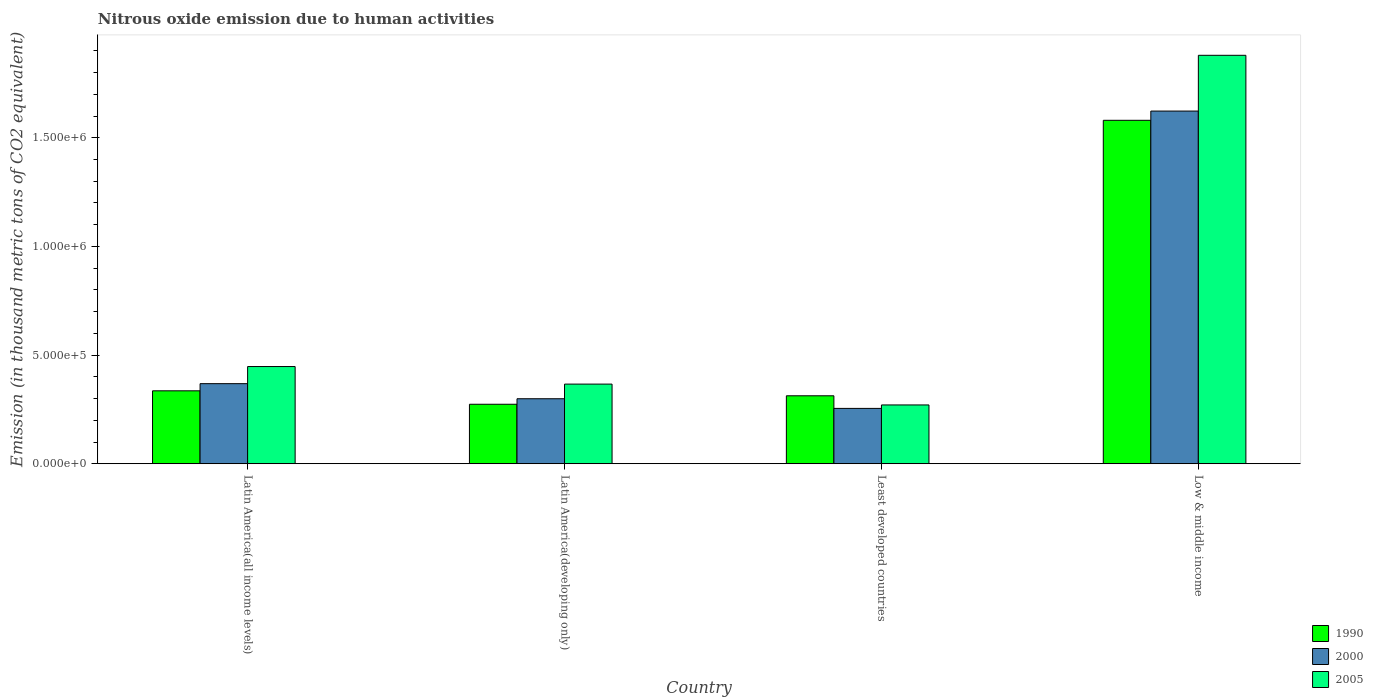How many different coloured bars are there?
Make the answer very short. 3. How many groups of bars are there?
Make the answer very short. 4. Are the number of bars per tick equal to the number of legend labels?
Make the answer very short. Yes. Are the number of bars on each tick of the X-axis equal?
Make the answer very short. Yes. What is the label of the 4th group of bars from the left?
Ensure brevity in your answer.  Low & middle income. In how many cases, is the number of bars for a given country not equal to the number of legend labels?
Give a very brief answer. 0. What is the amount of nitrous oxide emitted in 1990 in Latin America(developing only)?
Give a very brief answer. 2.74e+05. Across all countries, what is the maximum amount of nitrous oxide emitted in 2000?
Offer a very short reply. 1.62e+06. Across all countries, what is the minimum amount of nitrous oxide emitted in 2000?
Provide a succinct answer. 2.55e+05. In which country was the amount of nitrous oxide emitted in 2000 maximum?
Offer a very short reply. Low & middle income. In which country was the amount of nitrous oxide emitted in 1990 minimum?
Offer a terse response. Latin America(developing only). What is the total amount of nitrous oxide emitted in 2000 in the graph?
Offer a very short reply. 2.55e+06. What is the difference between the amount of nitrous oxide emitted in 2000 in Latin America(developing only) and that in Least developed countries?
Offer a terse response. 4.44e+04. What is the difference between the amount of nitrous oxide emitted in 2000 in Low & middle income and the amount of nitrous oxide emitted in 1990 in Least developed countries?
Make the answer very short. 1.31e+06. What is the average amount of nitrous oxide emitted in 2005 per country?
Make the answer very short. 7.41e+05. What is the difference between the amount of nitrous oxide emitted of/in 2000 and amount of nitrous oxide emitted of/in 1990 in Least developed countries?
Offer a terse response. -5.80e+04. What is the ratio of the amount of nitrous oxide emitted in 1990 in Latin America(all income levels) to that in Latin America(developing only)?
Ensure brevity in your answer.  1.23. Is the difference between the amount of nitrous oxide emitted in 2000 in Latin America(all income levels) and Latin America(developing only) greater than the difference between the amount of nitrous oxide emitted in 1990 in Latin America(all income levels) and Latin America(developing only)?
Make the answer very short. Yes. What is the difference between the highest and the second highest amount of nitrous oxide emitted in 2005?
Provide a succinct answer. -8.08e+04. What is the difference between the highest and the lowest amount of nitrous oxide emitted in 1990?
Your answer should be very brief. 1.31e+06. In how many countries, is the amount of nitrous oxide emitted in 2000 greater than the average amount of nitrous oxide emitted in 2000 taken over all countries?
Give a very brief answer. 1. Is the sum of the amount of nitrous oxide emitted in 2005 in Latin America(all income levels) and Low & middle income greater than the maximum amount of nitrous oxide emitted in 1990 across all countries?
Ensure brevity in your answer.  Yes. Is it the case that in every country, the sum of the amount of nitrous oxide emitted in 1990 and amount of nitrous oxide emitted in 2005 is greater than the amount of nitrous oxide emitted in 2000?
Your response must be concise. Yes. How many bars are there?
Offer a very short reply. 12. Does the graph contain grids?
Give a very brief answer. No. Where does the legend appear in the graph?
Provide a short and direct response. Bottom right. What is the title of the graph?
Keep it short and to the point. Nitrous oxide emission due to human activities. What is the label or title of the Y-axis?
Make the answer very short. Emission (in thousand metric tons of CO2 equivalent). What is the Emission (in thousand metric tons of CO2 equivalent) of 1990 in Latin America(all income levels)?
Ensure brevity in your answer.  3.36e+05. What is the Emission (in thousand metric tons of CO2 equivalent) in 2000 in Latin America(all income levels)?
Your response must be concise. 3.68e+05. What is the Emission (in thousand metric tons of CO2 equivalent) in 2005 in Latin America(all income levels)?
Keep it short and to the point. 4.47e+05. What is the Emission (in thousand metric tons of CO2 equivalent) in 1990 in Latin America(developing only)?
Provide a short and direct response. 2.74e+05. What is the Emission (in thousand metric tons of CO2 equivalent) of 2000 in Latin America(developing only)?
Offer a very short reply. 2.99e+05. What is the Emission (in thousand metric tons of CO2 equivalent) in 2005 in Latin America(developing only)?
Your answer should be compact. 3.66e+05. What is the Emission (in thousand metric tons of CO2 equivalent) of 1990 in Least developed countries?
Offer a terse response. 3.13e+05. What is the Emission (in thousand metric tons of CO2 equivalent) of 2000 in Least developed countries?
Your answer should be very brief. 2.55e+05. What is the Emission (in thousand metric tons of CO2 equivalent) of 2005 in Least developed countries?
Provide a short and direct response. 2.71e+05. What is the Emission (in thousand metric tons of CO2 equivalent) in 1990 in Low & middle income?
Keep it short and to the point. 1.58e+06. What is the Emission (in thousand metric tons of CO2 equivalent) of 2000 in Low & middle income?
Make the answer very short. 1.62e+06. What is the Emission (in thousand metric tons of CO2 equivalent) in 2005 in Low & middle income?
Keep it short and to the point. 1.88e+06. Across all countries, what is the maximum Emission (in thousand metric tons of CO2 equivalent) in 1990?
Make the answer very short. 1.58e+06. Across all countries, what is the maximum Emission (in thousand metric tons of CO2 equivalent) of 2000?
Offer a very short reply. 1.62e+06. Across all countries, what is the maximum Emission (in thousand metric tons of CO2 equivalent) in 2005?
Your response must be concise. 1.88e+06. Across all countries, what is the minimum Emission (in thousand metric tons of CO2 equivalent) in 1990?
Keep it short and to the point. 2.74e+05. Across all countries, what is the minimum Emission (in thousand metric tons of CO2 equivalent) of 2000?
Your response must be concise. 2.55e+05. Across all countries, what is the minimum Emission (in thousand metric tons of CO2 equivalent) in 2005?
Keep it short and to the point. 2.71e+05. What is the total Emission (in thousand metric tons of CO2 equivalent) of 1990 in the graph?
Make the answer very short. 2.50e+06. What is the total Emission (in thousand metric tons of CO2 equivalent) in 2000 in the graph?
Provide a succinct answer. 2.55e+06. What is the total Emission (in thousand metric tons of CO2 equivalent) of 2005 in the graph?
Offer a very short reply. 2.96e+06. What is the difference between the Emission (in thousand metric tons of CO2 equivalent) of 1990 in Latin America(all income levels) and that in Latin America(developing only)?
Your response must be concise. 6.18e+04. What is the difference between the Emission (in thousand metric tons of CO2 equivalent) of 2000 in Latin America(all income levels) and that in Latin America(developing only)?
Give a very brief answer. 6.94e+04. What is the difference between the Emission (in thousand metric tons of CO2 equivalent) of 2005 in Latin America(all income levels) and that in Latin America(developing only)?
Your answer should be compact. 8.08e+04. What is the difference between the Emission (in thousand metric tons of CO2 equivalent) of 1990 in Latin America(all income levels) and that in Least developed countries?
Provide a short and direct response. 2.29e+04. What is the difference between the Emission (in thousand metric tons of CO2 equivalent) in 2000 in Latin America(all income levels) and that in Least developed countries?
Your answer should be compact. 1.14e+05. What is the difference between the Emission (in thousand metric tons of CO2 equivalent) in 2005 in Latin America(all income levels) and that in Least developed countries?
Your response must be concise. 1.77e+05. What is the difference between the Emission (in thousand metric tons of CO2 equivalent) of 1990 in Latin America(all income levels) and that in Low & middle income?
Give a very brief answer. -1.24e+06. What is the difference between the Emission (in thousand metric tons of CO2 equivalent) in 2000 in Latin America(all income levels) and that in Low & middle income?
Provide a succinct answer. -1.25e+06. What is the difference between the Emission (in thousand metric tons of CO2 equivalent) in 2005 in Latin America(all income levels) and that in Low & middle income?
Provide a short and direct response. -1.43e+06. What is the difference between the Emission (in thousand metric tons of CO2 equivalent) of 1990 in Latin America(developing only) and that in Least developed countries?
Offer a very short reply. -3.90e+04. What is the difference between the Emission (in thousand metric tons of CO2 equivalent) of 2000 in Latin America(developing only) and that in Least developed countries?
Give a very brief answer. 4.44e+04. What is the difference between the Emission (in thousand metric tons of CO2 equivalent) of 2005 in Latin America(developing only) and that in Least developed countries?
Your answer should be very brief. 9.59e+04. What is the difference between the Emission (in thousand metric tons of CO2 equivalent) of 1990 in Latin America(developing only) and that in Low & middle income?
Your answer should be compact. -1.31e+06. What is the difference between the Emission (in thousand metric tons of CO2 equivalent) in 2000 in Latin America(developing only) and that in Low & middle income?
Offer a very short reply. -1.32e+06. What is the difference between the Emission (in thousand metric tons of CO2 equivalent) in 2005 in Latin America(developing only) and that in Low & middle income?
Ensure brevity in your answer.  -1.51e+06. What is the difference between the Emission (in thousand metric tons of CO2 equivalent) in 1990 in Least developed countries and that in Low & middle income?
Keep it short and to the point. -1.27e+06. What is the difference between the Emission (in thousand metric tons of CO2 equivalent) of 2000 in Least developed countries and that in Low & middle income?
Give a very brief answer. -1.37e+06. What is the difference between the Emission (in thousand metric tons of CO2 equivalent) in 2005 in Least developed countries and that in Low & middle income?
Keep it short and to the point. -1.61e+06. What is the difference between the Emission (in thousand metric tons of CO2 equivalent) in 1990 in Latin America(all income levels) and the Emission (in thousand metric tons of CO2 equivalent) in 2000 in Latin America(developing only)?
Keep it short and to the point. 3.65e+04. What is the difference between the Emission (in thousand metric tons of CO2 equivalent) in 1990 in Latin America(all income levels) and the Emission (in thousand metric tons of CO2 equivalent) in 2005 in Latin America(developing only)?
Keep it short and to the point. -3.09e+04. What is the difference between the Emission (in thousand metric tons of CO2 equivalent) of 2000 in Latin America(all income levels) and the Emission (in thousand metric tons of CO2 equivalent) of 2005 in Latin America(developing only)?
Ensure brevity in your answer.  2012. What is the difference between the Emission (in thousand metric tons of CO2 equivalent) of 1990 in Latin America(all income levels) and the Emission (in thousand metric tons of CO2 equivalent) of 2000 in Least developed countries?
Provide a short and direct response. 8.09e+04. What is the difference between the Emission (in thousand metric tons of CO2 equivalent) in 1990 in Latin America(all income levels) and the Emission (in thousand metric tons of CO2 equivalent) in 2005 in Least developed countries?
Make the answer very short. 6.50e+04. What is the difference between the Emission (in thousand metric tons of CO2 equivalent) in 2000 in Latin America(all income levels) and the Emission (in thousand metric tons of CO2 equivalent) in 2005 in Least developed countries?
Offer a very short reply. 9.79e+04. What is the difference between the Emission (in thousand metric tons of CO2 equivalent) in 1990 in Latin America(all income levels) and the Emission (in thousand metric tons of CO2 equivalent) in 2000 in Low & middle income?
Offer a very short reply. -1.29e+06. What is the difference between the Emission (in thousand metric tons of CO2 equivalent) in 1990 in Latin America(all income levels) and the Emission (in thousand metric tons of CO2 equivalent) in 2005 in Low & middle income?
Your answer should be compact. -1.54e+06. What is the difference between the Emission (in thousand metric tons of CO2 equivalent) of 2000 in Latin America(all income levels) and the Emission (in thousand metric tons of CO2 equivalent) of 2005 in Low & middle income?
Provide a short and direct response. -1.51e+06. What is the difference between the Emission (in thousand metric tons of CO2 equivalent) in 1990 in Latin America(developing only) and the Emission (in thousand metric tons of CO2 equivalent) in 2000 in Least developed countries?
Ensure brevity in your answer.  1.91e+04. What is the difference between the Emission (in thousand metric tons of CO2 equivalent) in 1990 in Latin America(developing only) and the Emission (in thousand metric tons of CO2 equivalent) in 2005 in Least developed countries?
Your response must be concise. 3144.7. What is the difference between the Emission (in thousand metric tons of CO2 equivalent) in 2000 in Latin America(developing only) and the Emission (in thousand metric tons of CO2 equivalent) in 2005 in Least developed countries?
Offer a very short reply. 2.85e+04. What is the difference between the Emission (in thousand metric tons of CO2 equivalent) of 1990 in Latin America(developing only) and the Emission (in thousand metric tons of CO2 equivalent) of 2000 in Low & middle income?
Make the answer very short. -1.35e+06. What is the difference between the Emission (in thousand metric tons of CO2 equivalent) of 1990 in Latin America(developing only) and the Emission (in thousand metric tons of CO2 equivalent) of 2005 in Low & middle income?
Your response must be concise. -1.61e+06. What is the difference between the Emission (in thousand metric tons of CO2 equivalent) in 2000 in Latin America(developing only) and the Emission (in thousand metric tons of CO2 equivalent) in 2005 in Low & middle income?
Provide a succinct answer. -1.58e+06. What is the difference between the Emission (in thousand metric tons of CO2 equivalent) of 1990 in Least developed countries and the Emission (in thousand metric tons of CO2 equivalent) of 2000 in Low & middle income?
Offer a very short reply. -1.31e+06. What is the difference between the Emission (in thousand metric tons of CO2 equivalent) in 1990 in Least developed countries and the Emission (in thousand metric tons of CO2 equivalent) in 2005 in Low & middle income?
Keep it short and to the point. -1.57e+06. What is the difference between the Emission (in thousand metric tons of CO2 equivalent) in 2000 in Least developed countries and the Emission (in thousand metric tons of CO2 equivalent) in 2005 in Low & middle income?
Make the answer very short. -1.62e+06. What is the average Emission (in thousand metric tons of CO2 equivalent) of 1990 per country?
Give a very brief answer. 6.26e+05. What is the average Emission (in thousand metric tons of CO2 equivalent) in 2000 per country?
Your answer should be compact. 6.36e+05. What is the average Emission (in thousand metric tons of CO2 equivalent) of 2005 per country?
Make the answer very short. 7.41e+05. What is the difference between the Emission (in thousand metric tons of CO2 equivalent) of 1990 and Emission (in thousand metric tons of CO2 equivalent) of 2000 in Latin America(all income levels)?
Your response must be concise. -3.29e+04. What is the difference between the Emission (in thousand metric tons of CO2 equivalent) in 1990 and Emission (in thousand metric tons of CO2 equivalent) in 2005 in Latin America(all income levels)?
Your response must be concise. -1.12e+05. What is the difference between the Emission (in thousand metric tons of CO2 equivalent) in 2000 and Emission (in thousand metric tons of CO2 equivalent) in 2005 in Latin America(all income levels)?
Offer a terse response. -7.88e+04. What is the difference between the Emission (in thousand metric tons of CO2 equivalent) in 1990 and Emission (in thousand metric tons of CO2 equivalent) in 2000 in Latin America(developing only)?
Your answer should be compact. -2.54e+04. What is the difference between the Emission (in thousand metric tons of CO2 equivalent) in 1990 and Emission (in thousand metric tons of CO2 equivalent) in 2005 in Latin America(developing only)?
Your response must be concise. -9.27e+04. What is the difference between the Emission (in thousand metric tons of CO2 equivalent) in 2000 and Emission (in thousand metric tons of CO2 equivalent) in 2005 in Latin America(developing only)?
Offer a very short reply. -6.74e+04. What is the difference between the Emission (in thousand metric tons of CO2 equivalent) in 1990 and Emission (in thousand metric tons of CO2 equivalent) in 2000 in Least developed countries?
Ensure brevity in your answer.  5.80e+04. What is the difference between the Emission (in thousand metric tons of CO2 equivalent) in 1990 and Emission (in thousand metric tons of CO2 equivalent) in 2005 in Least developed countries?
Make the answer very short. 4.21e+04. What is the difference between the Emission (in thousand metric tons of CO2 equivalent) in 2000 and Emission (in thousand metric tons of CO2 equivalent) in 2005 in Least developed countries?
Offer a terse response. -1.59e+04. What is the difference between the Emission (in thousand metric tons of CO2 equivalent) of 1990 and Emission (in thousand metric tons of CO2 equivalent) of 2000 in Low & middle income?
Your response must be concise. -4.25e+04. What is the difference between the Emission (in thousand metric tons of CO2 equivalent) in 1990 and Emission (in thousand metric tons of CO2 equivalent) in 2005 in Low & middle income?
Give a very brief answer. -2.99e+05. What is the difference between the Emission (in thousand metric tons of CO2 equivalent) of 2000 and Emission (in thousand metric tons of CO2 equivalent) of 2005 in Low & middle income?
Give a very brief answer. -2.57e+05. What is the ratio of the Emission (in thousand metric tons of CO2 equivalent) in 1990 in Latin America(all income levels) to that in Latin America(developing only)?
Offer a terse response. 1.23. What is the ratio of the Emission (in thousand metric tons of CO2 equivalent) of 2000 in Latin America(all income levels) to that in Latin America(developing only)?
Your response must be concise. 1.23. What is the ratio of the Emission (in thousand metric tons of CO2 equivalent) in 2005 in Latin America(all income levels) to that in Latin America(developing only)?
Your response must be concise. 1.22. What is the ratio of the Emission (in thousand metric tons of CO2 equivalent) of 1990 in Latin America(all income levels) to that in Least developed countries?
Ensure brevity in your answer.  1.07. What is the ratio of the Emission (in thousand metric tons of CO2 equivalent) of 2000 in Latin America(all income levels) to that in Least developed countries?
Give a very brief answer. 1.45. What is the ratio of the Emission (in thousand metric tons of CO2 equivalent) in 2005 in Latin America(all income levels) to that in Least developed countries?
Give a very brief answer. 1.65. What is the ratio of the Emission (in thousand metric tons of CO2 equivalent) in 1990 in Latin America(all income levels) to that in Low & middle income?
Your answer should be compact. 0.21. What is the ratio of the Emission (in thousand metric tons of CO2 equivalent) in 2000 in Latin America(all income levels) to that in Low & middle income?
Keep it short and to the point. 0.23. What is the ratio of the Emission (in thousand metric tons of CO2 equivalent) of 2005 in Latin America(all income levels) to that in Low & middle income?
Make the answer very short. 0.24. What is the ratio of the Emission (in thousand metric tons of CO2 equivalent) in 1990 in Latin America(developing only) to that in Least developed countries?
Make the answer very short. 0.88. What is the ratio of the Emission (in thousand metric tons of CO2 equivalent) of 2000 in Latin America(developing only) to that in Least developed countries?
Ensure brevity in your answer.  1.17. What is the ratio of the Emission (in thousand metric tons of CO2 equivalent) in 2005 in Latin America(developing only) to that in Least developed countries?
Provide a short and direct response. 1.35. What is the ratio of the Emission (in thousand metric tons of CO2 equivalent) in 1990 in Latin America(developing only) to that in Low & middle income?
Provide a short and direct response. 0.17. What is the ratio of the Emission (in thousand metric tons of CO2 equivalent) of 2000 in Latin America(developing only) to that in Low & middle income?
Your response must be concise. 0.18. What is the ratio of the Emission (in thousand metric tons of CO2 equivalent) in 2005 in Latin America(developing only) to that in Low & middle income?
Provide a short and direct response. 0.2. What is the ratio of the Emission (in thousand metric tons of CO2 equivalent) in 1990 in Least developed countries to that in Low & middle income?
Your response must be concise. 0.2. What is the ratio of the Emission (in thousand metric tons of CO2 equivalent) of 2000 in Least developed countries to that in Low & middle income?
Provide a succinct answer. 0.16. What is the ratio of the Emission (in thousand metric tons of CO2 equivalent) of 2005 in Least developed countries to that in Low & middle income?
Provide a short and direct response. 0.14. What is the difference between the highest and the second highest Emission (in thousand metric tons of CO2 equivalent) of 1990?
Your response must be concise. 1.24e+06. What is the difference between the highest and the second highest Emission (in thousand metric tons of CO2 equivalent) of 2000?
Your answer should be very brief. 1.25e+06. What is the difference between the highest and the second highest Emission (in thousand metric tons of CO2 equivalent) of 2005?
Ensure brevity in your answer.  1.43e+06. What is the difference between the highest and the lowest Emission (in thousand metric tons of CO2 equivalent) in 1990?
Your answer should be very brief. 1.31e+06. What is the difference between the highest and the lowest Emission (in thousand metric tons of CO2 equivalent) of 2000?
Provide a succinct answer. 1.37e+06. What is the difference between the highest and the lowest Emission (in thousand metric tons of CO2 equivalent) of 2005?
Offer a terse response. 1.61e+06. 